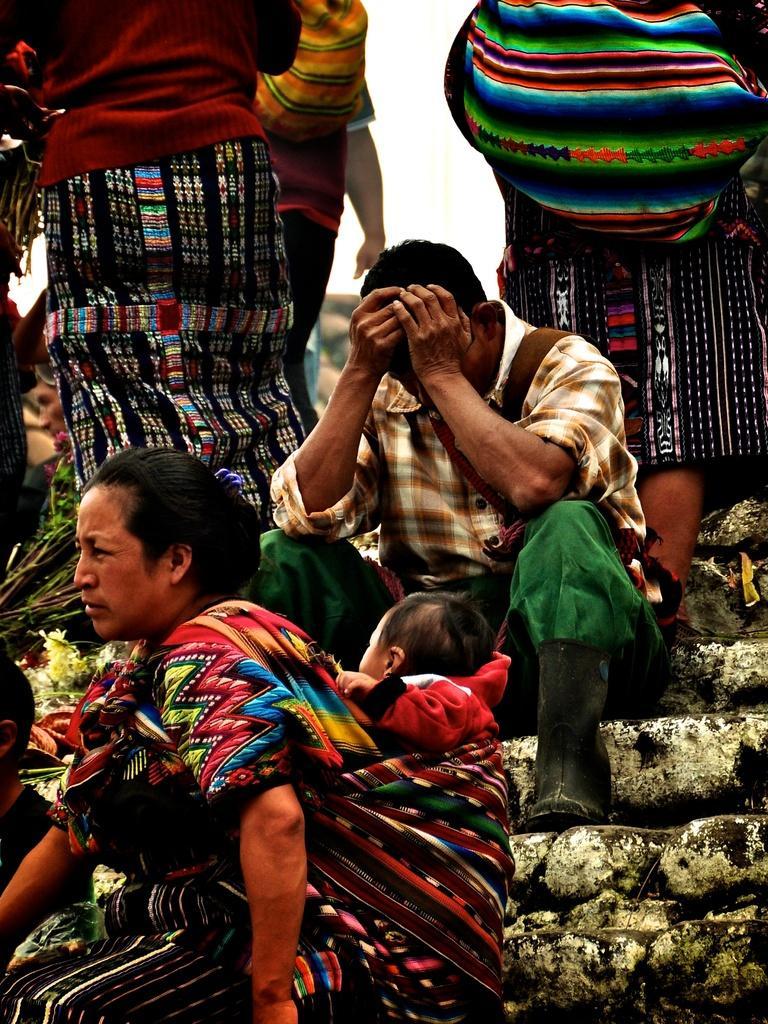Please provide a concise description of this image. In this picture I can see group of people sitting on the stairs, there is a woman carrying a baby, there are three persons standing, and in the background there is sky. 